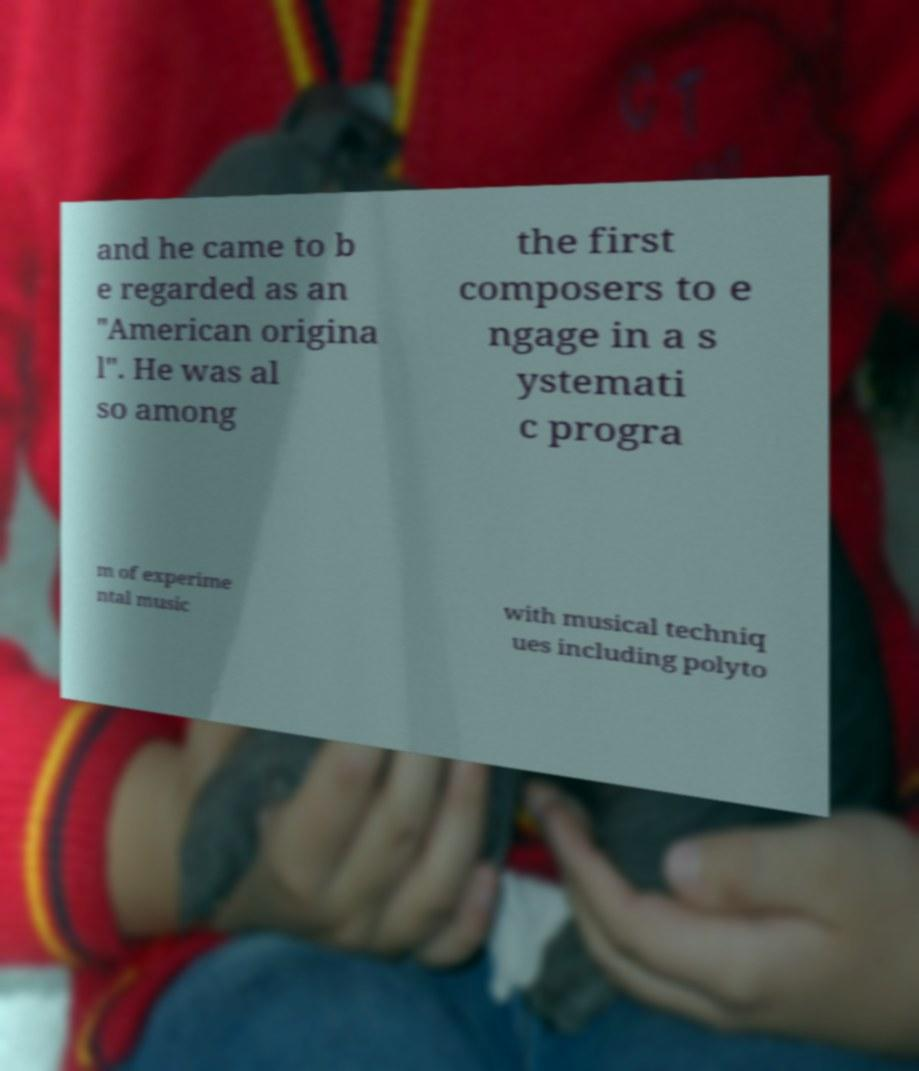Could you extract and type out the text from this image? and he came to b e regarded as an "American origina l". He was al so among the first composers to e ngage in a s ystemati c progra m of experime ntal music with musical techniq ues including polyto 